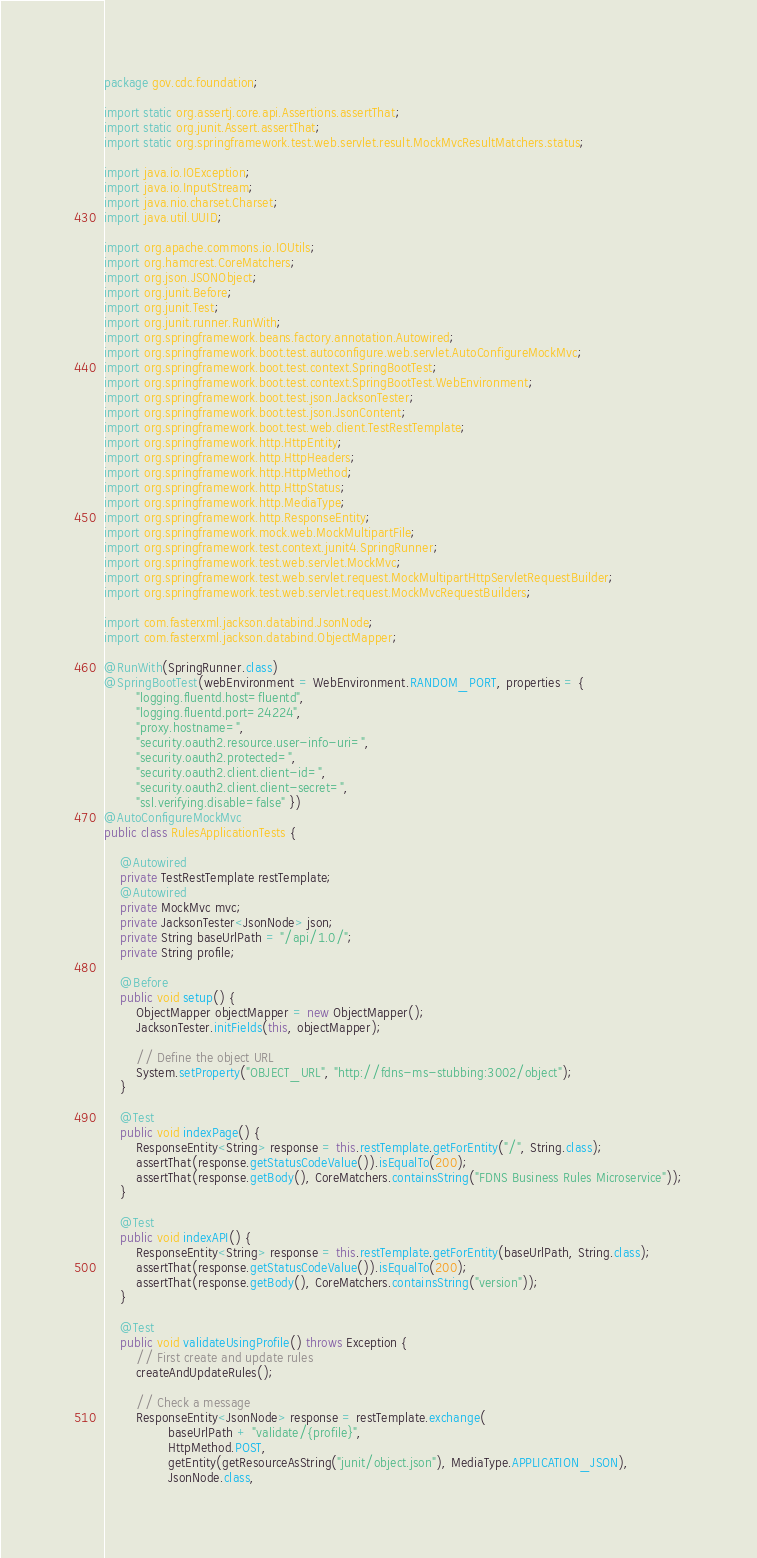Convert code to text. <code><loc_0><loc_0><loc_500><loc_500><_Java_>package gov.cdc.foundation;

import static org.assertj.core.api.Assertions.assertThat;
import static org.junit.Assert.assertThat;
import static org.springframework.test.web.servlet.result.MockMvcResultMatchers.status;

import java.io.IOException;
import java.io.InputStream;
import java.nio.charset.Charset;
import java.util.UUID;

import org.apache.commons.io.IOUtils;
import org.hamcrest.CoreMatchers;
import org.json.JSONObject;
import org.junit.Before;
import org.junit.Test;
import org.junit.runner.RunWith;
import org.springframework.beans.factory.annotation.Autowired;
import org.springframework.boot.test.autoconfigure.web.servlet.AutoConfigureMockMvc;
import org.springframework.boot.test.context.SpringBootTest;
import org.springframework.boot.test.context.SpringBootTest.WebEnvironment;
import org.springframework.boot.test.json.JacksonTester;
import org.springframework.boot.test.json.JsonContent;
import org.springframework.boot.test.web.client.TestRestTemplate;
import org.springframework.http.HttpEntity;
import org.springframework.http.HttpHeaders;
import org.springframework.http.HttpMethod;
import org.springframework.http.HttpStatus;
import org.springframework.http.MediaType;
import org.springframework.http.ResponseEntity;
import org.springframework.mock.web.MockMultipartFile;
import org.springframework.test.context.junit4.SpringRunner;
import org.springframework.test.web.servlet.MockMvc;
import org.springframework.test.web.servlet.request.MockMultipartHttpServletRequestBuilder;
import org.springframework.test.web.servlet.request.MockMvcRequestBuilders;

import com.fasterxml.jackson.databind.JsonNode;
import com.fasterxml.jackson.databind.ObjectMapper;

@RunWith(SpringRunner.class)
@SpringBootTest(webEnvironment = WebEnvironment.RANDOM_PORT, properties = { 
		"logging.fluentd.host=fluentd", 
		"logging.fluentd.port=24224", 
		"proxy.hostname=",
		"security.oauth2.resource.user-info-uri=",
		"security.oauth2.protected=",
		"security.oauth2.client.client-id=",
		"security.oauth2.client.client-secret=",
		"ssl.verifying.disable=false" })
@AutoConfigureMockMvc
public class RulesApplicationTests {

	@Autowired
	private TestRestTemplate restTemplate;
	@Autowired
	private MockMvc mvc;
	private JacksonTester<JsonNode> json;
	private String baseUrlPath = "/api/1.0/";
	private String profile;

	@Before
	public void setup() {
		ObjectMapper objectMapper = new ObjectMapper();
		JacksonTester.initFields(this, objectMapper);

		// Define the object URL
		System.setProperty("OBJECT_URL", "http://fdns-ms-stubbing:3002/object");
	}

	@Test
	public void indexPage() {
		ResponseEntity<String> response = this.restTemplate.getForEntity("/", String.class);
		assertThat(response.getStatusCodeValue()).isEqualTo(200);
		assertThat(response.getBody(), CoreMatchers.containsString("FDNS Business Rules Microservice"));
	}

	@Test
	public void indexAPI() {
		ResponseEntity<String> response = this.restTemplate.getForEntity(baseUrlPath, String.class);
		assertThat(response.getStatusCodeValue()).isEqualTo(200);
		assertThat(response.getBody(), CoreMatchers.containsString("version"));
	}

	@Test
	public void validateUsingProfile() throws Exception {
		// First create and update rules
		createAndUpdateRules();
		
		// Check a message
		ResponseEntity<JsonNode> response = restTemplate.exchange(
				baseUrlPath + "validate/{profile}", 
				HttpMethod.POST, 
				getEntity(getResourceAsString("junit/object.json"), MediaType.APPLICATION_JSON), 
				JsonNode.class,</code> 